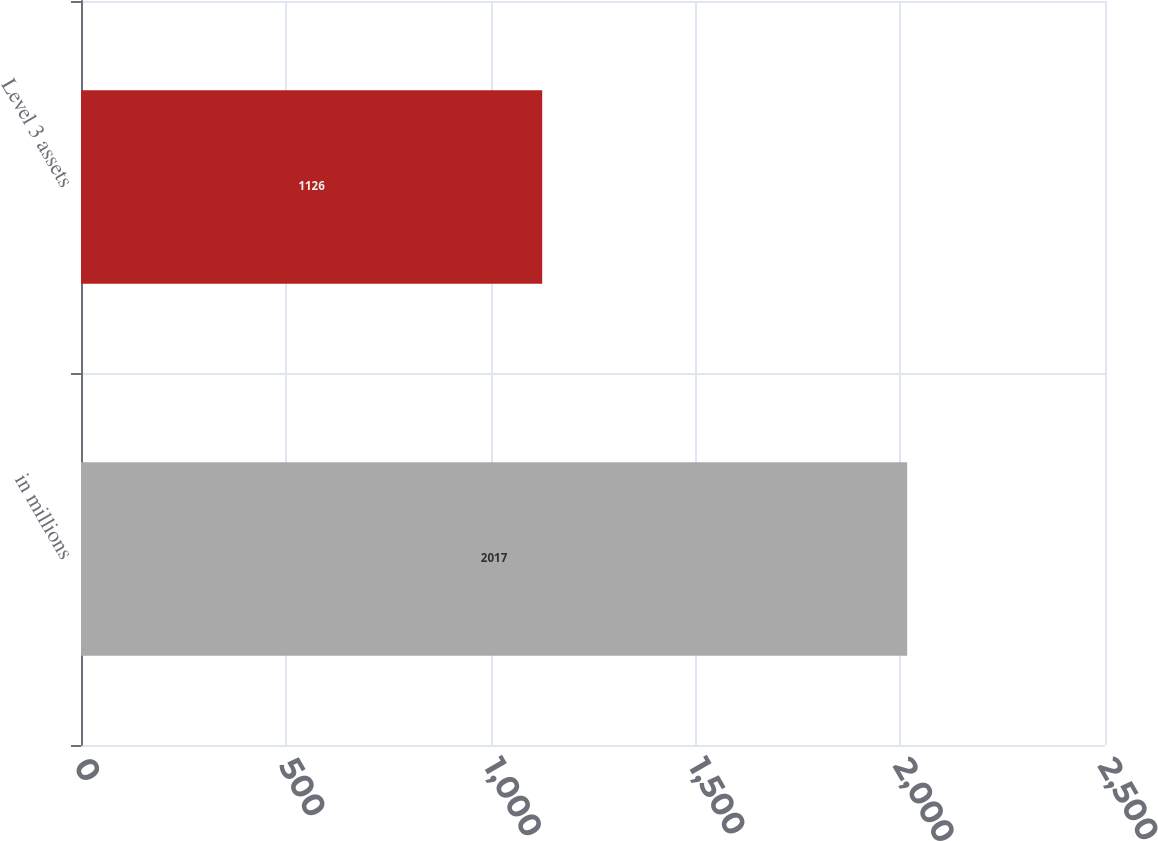<chart> <loc_0><loc_0><loc_500><loc_500><bar_chart><fcel>in millions<fcel>Level 3 assets<nl><fcel>2017<fcel>1126<nl></chart> 